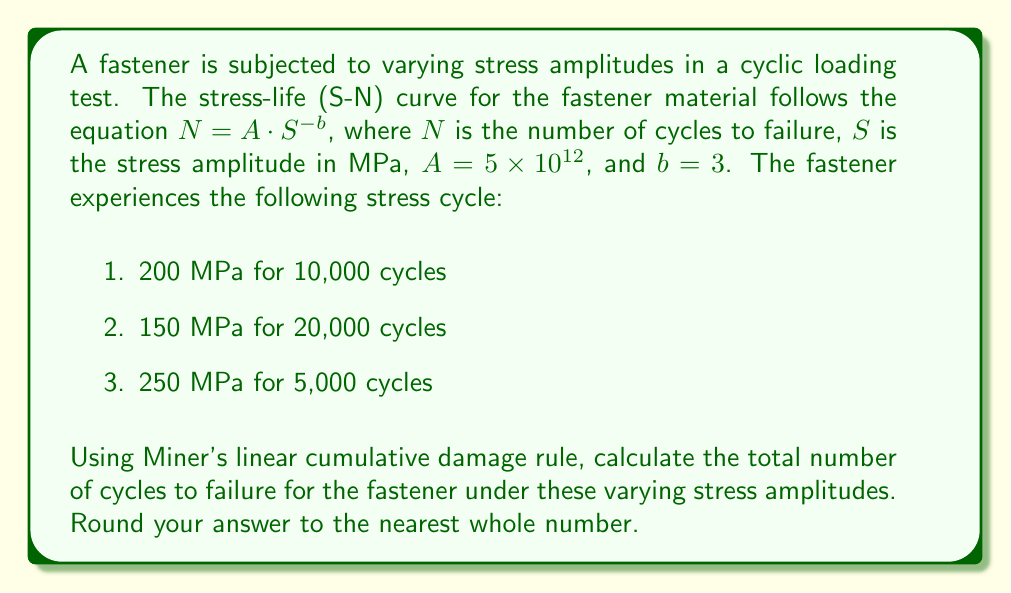Can you answer this question? To solve this problem, we'll follow these steps:

1. Calculate the number of cycles to failure (Nf) for each stress amplitude using the S-N curve equation.
2. Calculate the damage fraction (n/Nf) for each stress level.
3. Sum the damage fractions and set the sum equal to 1 to find the total number of cycles to failure.

Step 1: Calculate Nf for each stress amplitude

S-N curve equation: $N = A \cdot S^{-b}$, where $A = 5 \times 10^{12}$ and $b = 3$

For 200 MPa: 
$$N_1 = 5 \times 10^{12} \cdot (200)^{-3} = 625,000 \text{ cycles}$$

For 150 MPa:
$$N_2 = 5 \times 10^{12} \cdot (150)^{-3} = 1,481,481 \text{ cycles}$$

For 250 MPa:
$$N_3 = 5 \times 10^{12} \cdot (250)^{-3} = 320,000 \text{ cycles}$$

Step 2: Calculate damage fractions

For 200 MPa: $\frac{n_1}{N_1} = \frac{10,000}{625,000} = 0.016$

For 150 MPa: $\frac{n_2}{N_2} = \frac{20,000}{1,481,481} = 0.0135$

For 250 MPa: $\frac{n_3}{N_3} = \frac{5,000}{320,000} = 0.015625$

Step 3: Apply Miner's rule

According to Miner's rule, failure occurs when:

$$\sum_{i=1}^{k} \frac{n_i}{N_i} = 1$$

Let x be the factor by which we need to multiply the given cycles to reach failure:

$$x \cdot (0.016 + 0.0135 + 0.015625) = 1$$
$$x \cdot 0.045125 = 1$$
$$x = \frac{1}{0.045125} = 22.16$$

Total cycles to failure:
$$(10,000 + 20,000 + 5,000) \cdot 22.16 = 777,600 \text{ cycles}$$

Rounding to the nearest whole number: 777,600 cycles
Answer: 777,600 cycles 